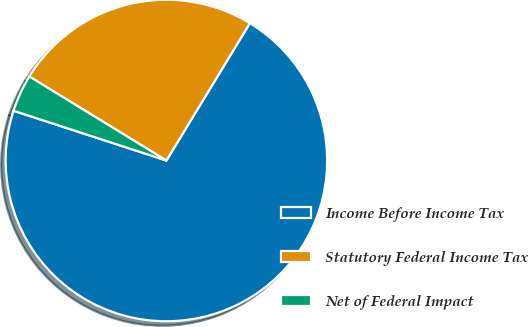Convert chart to OTSL. <chart><loc_0><loc_0><loc_500><loc_500><pie_chart><fcel>Income Before Income Tax<fcel>Statutory Federal Income Tax<fcel>Net of Federal Impact<nl><fcel>71.32%<fcel>24.94%<fcel>3.74%<nl></chart> 